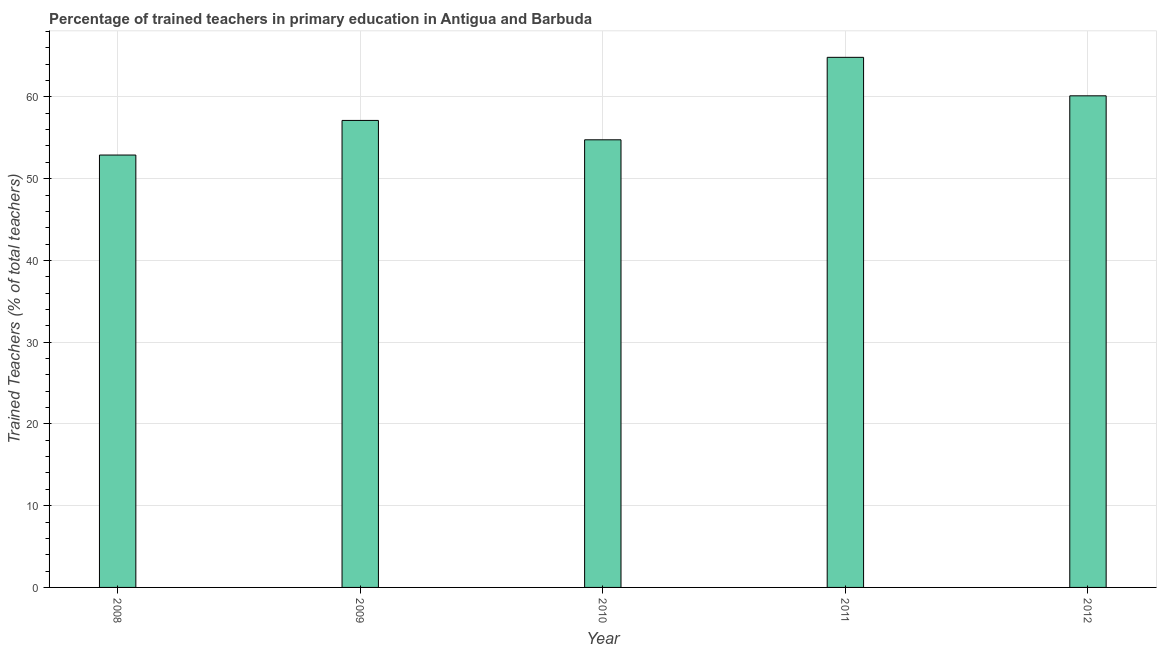Does the graph contain any zero values?
Keep it short and to the point. No. What is the title of the graph?
Offer a very short reply. Percentage of trained teachers in primary education in Antigua and Barbuda. What is the label or title of the Y-axis?
Ensure brevity in your answer.  Trained Teachers (% of total teachers). What is the percentage of trained teachers in 2009?
Offer a terse response. 57.12. Across all years, what is the maximum percentage of trained teachers?
Your response must be concise. 64.84. Across all years, what is the minimum percentage of trained teachers?
Your answer should be very brief. 52.89. In which year was the percentage of trained teachers maximum?
Provide a short and direct response. 2011. What is the sum of the percentage of trained teachers?
Your answer should be very brief. 289.74. What is the difference between the percentage of trained teachers in 2011 and 2012?
Your answer should be very brief. 4.71. What is the average percentage of trained teachers per year?
Your response must be concise. 57.95. What is the median percentage of trained teachers?
Your response must be concise. 57.12. In how many years, is the percentage of trained teachers greater than 56 %?
Provide a short and direct response. 3. Do a majority of the years between 2010 and 2012 (inclusive) have percentage of trained teachers greater than 4 %?
Make the answer very short. Yes. What is the ratio of the percentage of trained teachers in 2008 to that in 2009?
Ensure brevity in your answer.  0.93. Is the percentage of trained teachers in 2009 less than that in 2012?
Provide a succinct answer. Yes. What is the difference between the highest and the second highest percentage of trained teachers?
Provide a succinct answer. 4.71. What is the difference between the highest and the lowest percentage of trained teachers?
Your response must be concise. 11.95. Are all the bars in the graph horizontal?
Make the answer very short. No. How many years are there in the graph?
Your answer should be very brief. 5. What is the difference between two consecutive major ticks on the Y-axis?
Keep it short and to the point. 10. What is the Trained Teachers (% of total teachers) in 2008?
Offer a very short reply. 52.89. What is the Trained Teachers (% of total teachers) of 2009?
Your response must be concise. 57.12. What is the Trained Teachers (% of total teachers) of 2010?
Your response must be concise. 54.75. What is the Trained Teachers (% of total teachers) of 2011?
Make the answer very short. 64.84. What is the Trained Teachers (% of total teachers) in 2012?
Provide a succinct answer. 60.13. What is the difference between the Trained Teachers (% of total teachers) in 2008 and 2009?
Give a very brief answer. -4.23. What is the difference between the Trained Teachers (% of total teachers) in 2008 and 2010?
Provide a succinct answer. -1.86. What is the difference between the Trained Teachers (% of total teachers) in 2008 and 2011?
Your response must be concise. -11.95. What is the difference between the Trained Teachers (% of total teachers) in 2008 and 2012?
Offer a very short reply. -7.24. What is the difference between the Trained Teachers (% of total teachers) in 2009 and 2010?
Ensure brevity in your answer.  2.37. What is the difference between the Trained Teachers (% of total teachers) in 2009 and 2011?
Offer a very short reply. -7.72. What is the difference between the Trained Teachers (% of total teachers) in 2009 and 2012?
Keep it short and to the point. -3.01. What is the difference between the Trained Teachers (% of total teachers) in 2010 and 2011?
Offer a very short reply. -10.09. What is the difference between the Trained Teachers (% of total teachers) in 2010 and 2012?
Your answer should be very brief. -5.38. What is the difference between the Trained Teachers (% of total teachers) in 2011 and 2012?
Provide a succinct answer. 4.71. What is the ratio of the Trained Teachers (% of total teachers) in 2008 to that in 2009?
Keep it short and to the point. 0.93. What is the ratio of the Trained Teachers (% of total teachers) in 2008 to that in 2011?
Provide a succinct answer. 0.82. What is the ratio of the Trained Teachers (% of total teachers) in 2008 to that in 2012?
Your answer should be very brief. 0.88. What is the ratio of the Trained Teachers (% of total teachers) in 2009 to that in 2010?
Offer a very short reply. 1.04. What is the ratio of the Trained Teachers (% of total teachers) in 2009 to that in 2011?
Offer a very short reply. 0.88. What is the ratio of the Trained Teachers (% of total teachers) in 2009 to that in 2012?
Make the answer very short. 0.95. What is the ratio of the Trained Teachers (% of total teachers) in 2010 to that in 2011?
Ensure brevity in your answer.  0.84. What is the ratio of the Trained Teachers (% of total teachers) in 2010 to that in 2012?
Offer a very short reply. 0.91. What is the ratio of the Trained Teachers (% of total teachers) in 2011 to that in 2012?
Keep it short and to the point. 1.08. 